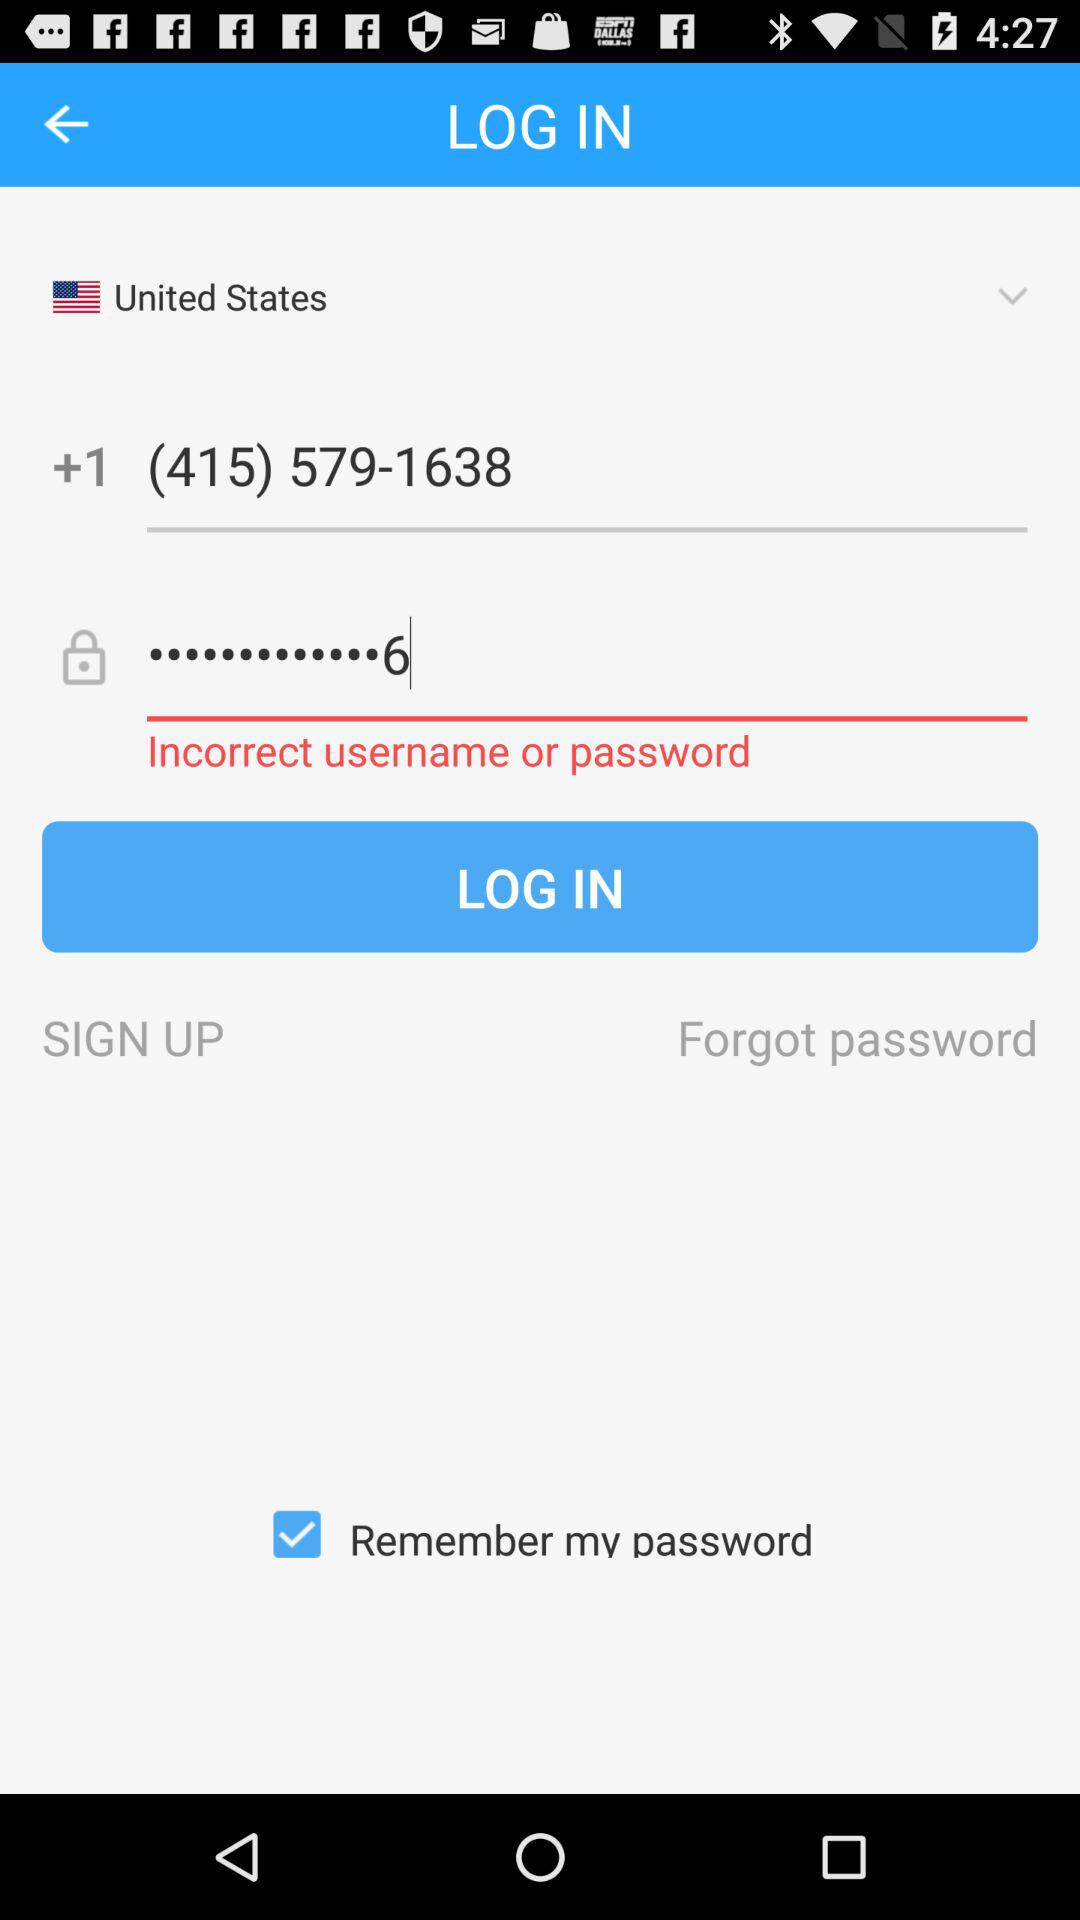How many characters are required to create a password?
When the provided information is insufficient, respond with <no answer>. <no answer> 